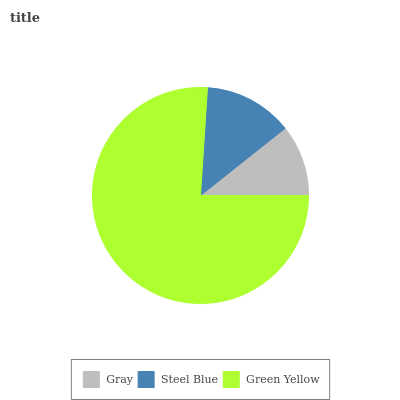Is Gray the minimum?
Answer yes or no. Yes. Is Green Yellow the maximum?
Answer yes or no. Yes. Is Steel Blue the minimum?
Answer yes or no. No. Is Steel Blue the maximum?
Answer yes or no. No. Is Steel Blue greater than Gray?
Answer yes or no. Yes. Is Gray less than Steel Blue?
Answer yes or no. Yes. Is Gray greater than Steel Blue?
Answer yes or no. No. Is Steel Blue less than Gray?
Answer yes or no. No. Is Steel Blue the high median?
Answer yes or no. Yes. Is Steel Blue the low median?
Answer yes or no. Yes. Is Green Yellow the high median?
Answer yes or no. No. Is Green Yellow the low median?
Answer yes or no. No. 